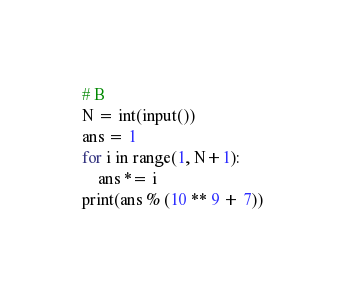Convert code to text. <code><loc_0><loc_0><loc_500><loc_500><_Python_># B
N = int(input())
ans = 1
for i in range(1, N+1):
    ans *= i
print(ans % (10 ** 9 + 7))</code> 